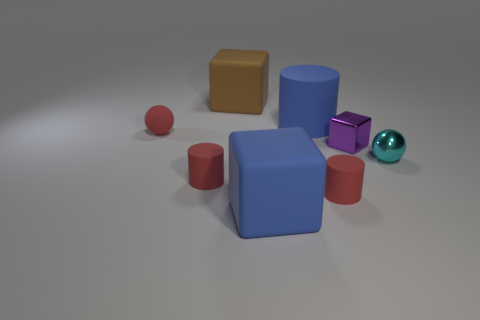Subtract all green cubes. Subtract all purple cylinders. How many cubes are left? 3 Add 1 cyan things. How many objects exist? 9 Subtract all balls. How many objects are left? 6 Subtract all red matte objects. Subtract all tiny cyan balls. How many objects are left? 4 Add 1 small red rubber balls. How many small red rubber balls are left? 2 Add 2 purple rubber cylinders. How many purple rubber cylinders exist? 2 Subtract 0 blue balls. How many objects are left? 8 